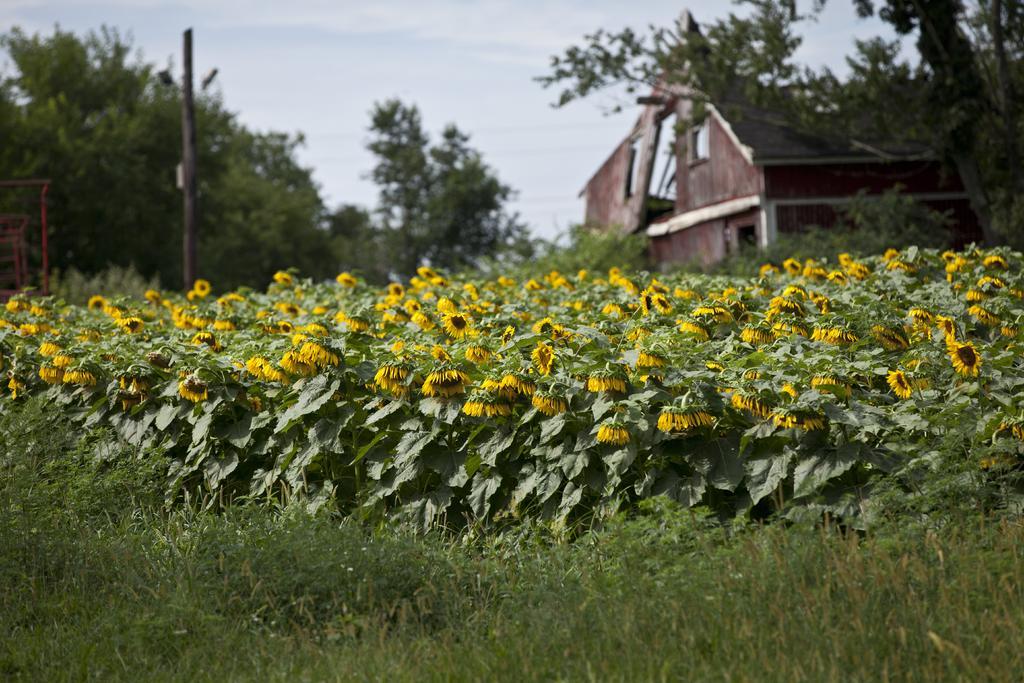How would you summarize this image in a sentence or two? In the background we can see the sky, trees and house. In this picture we can see grass, plants, flowers. On the left side of the picture we can see objects. 